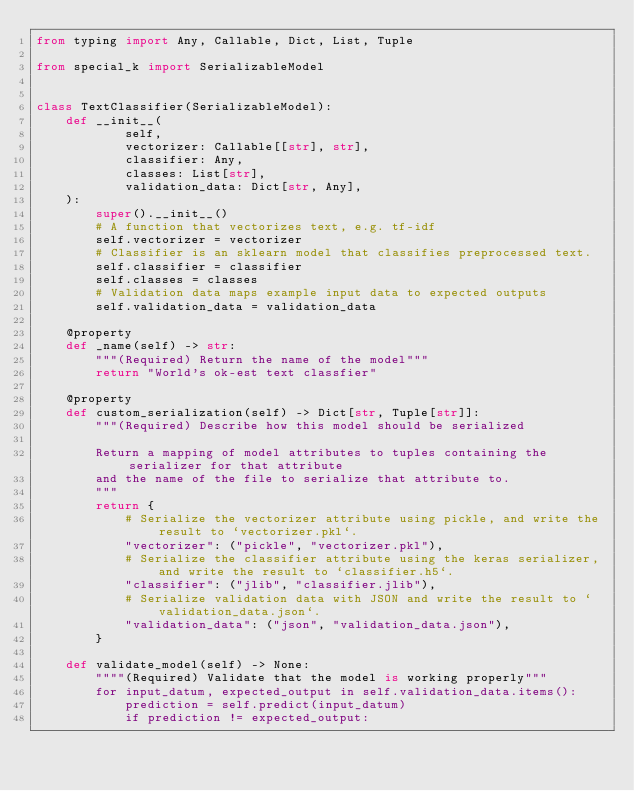<code> <loc_0><loc_0><loc_500><loc_500><_Python_>from typing import Any, Callable, Dict, List, Tuple

from special_k import SerializableModel


class TextClassifier(SerializableModel):
    def __init__(
            self,
            vectorizer: Callable[[str], str],
            classifier: Any,
            classes: List[str],
            validation_data: Dict[str, Any],
    ):
        super().__init__()
        # A function that vectorizes text, e.g. tf-idf
        self.vectorizer = vectorizer
        # Classifier is an sklearn model that classifies preprocessed text.
        self.classifier = classifier
        self.classes = classes
        # Validation data maps example input data to expected outputs
        self.validation_data = validation_data

    @property
    def _name(self) -> str:
        """(Required) Return the name of the model"""
        return "World's ok-est text classfier"

    @property
    def custom_serialization(self) -> Dict[str, Tuple[str]]:
        """(Required) Describe how this model should be serialized
        
        Return a mapping of model attributes to tuples containing the serializer for that attribute
        and the name of the file to serialize that attribute to.
        """
        return {
            # Serialize the vectorizer attribute using pickle, and write the result to `vectorizer.pkl`.
            "vectorizer": ("pickle", "vectorizer.pkl"),
            # Serialize the classifier attribute using the keras serializer, and write the result to `classifier.h5`.
            "classifier": ("jlib", "classifier.jlib"),
            # Serialize validation data with JSON and write the result to `validation_data.json`.
            "validation_data": ("json", "validation_data.json"),
        }

    def validate_model(self) -> None:
        """"(Required) Validate that the model is working properly"""
        for input_datum, expected_output in self.validation_data.items():
            prediction = self.predict(input_datum)
            if prediction != expected_output:</code> 